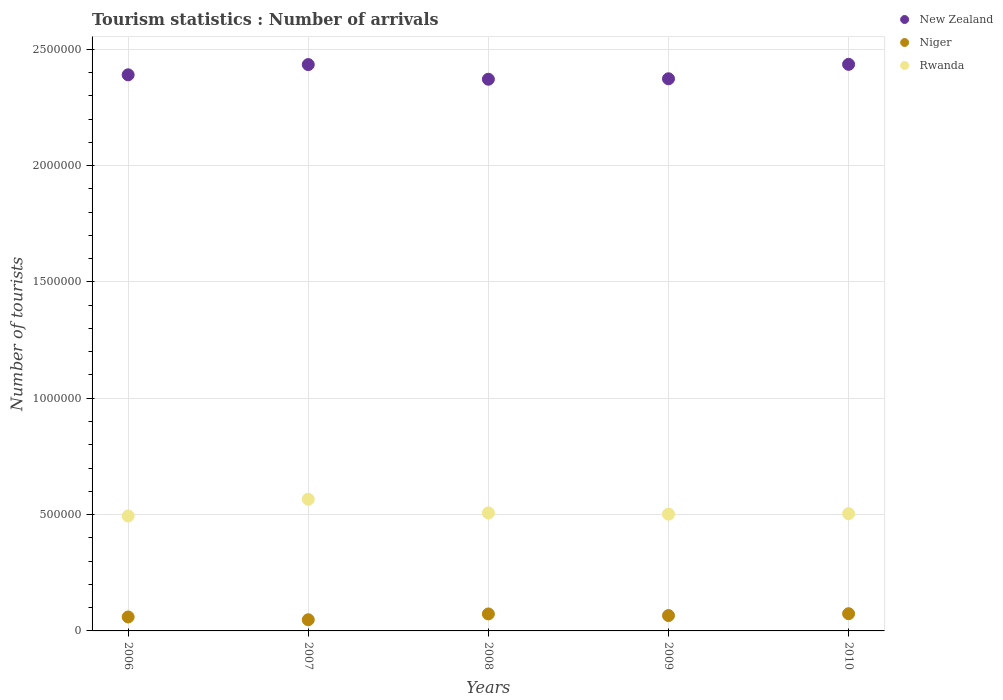How many different coloured dotlines are there?
Keep it short and to the point. 3. What is the number of tourist arrivals in New Zealand in 2007?
Keep it short and to the point. 2.43e+06. Across all years, what is the maximum number of tourist arrivals in Niger?
Make the answer very short. 7.40e+04. Across all years, what is the minimum number of tourist arrivals in Rwanda?
Keep it short and to the point. 4.94e+05. In which year was the number of tourist arrivals in Niger maximum?
Keep it short and to the point. 2010. What is the total number of tourist arrivals in New Zealand in the graph?
Give a very brief answer. 1.20e+07. What is the difference between the number of tourist arrivals in New Zealand in 2006 and that in 2009?
Your response must be concise. 1.70e+04. What is the difference between the number of tourist arrivals in Rwanda in 2008 and the number of tourist arrivals in Niger in 2010?
Give a very brief answer. 4.33e+05. What is the average number of tourist arrivals in Niger per year?
Ensure brevity in your answer.  6.42e+04. In the year 2010, what is the difference between the number of tourist arrivals in Niger and number of tourist arrivals in New Zealand?
Ensure brevity in your answer.  -2.36e+06. In how many years, is the number of tourist arrivals in New Zealand greater than 1300000?
Your answer should be compact. 5. What is the ratio of the number of tourist arrivals in Rwanda in 2006 to that in 2009?
Provide a short and direct response. 0.98. Is the number of tourist arrivals in Niger in 2007 less than that in 2009?
Your response must be concise. Yes. Is the difference between the number of tourist arrivals in Niger in 2008 and 2009 greater than the difference between the number of tourist arrivals in New Zealand in 2008 and 2009?
Keep it short and to the point. Yes. What is the difference between the highest and the lowest number of tourist arrivals in New Zealand?
Your response must be concise. 6.40e+04. In how many years, is the number of tourist arrivals in Rwanda greater than the average number of tourist arrivals in Rwanda taken over all years?
Offer a terse response. 1. Is the sum of the number of tourist arrivals in Niger in 2007 and 2008 greater than the maximum number of tourist arrivals in New Zealand across all years?
Offer a very short reply. No. Is it the case that in every year, the sum of the number of tourist arrivals in Niger and number of tourist arrivals in New Zealand  is greater than the number of tourist arrivals in Rwanda?
Provide a short and direct response. Yes. Does the number of tourist arrivals in Rwanda monotonically increase over the years?
Your answer should be compact. No. Are the values on the major ticks of Y-axis written in scientific E-notation?
Offer a terse response. No. Does the graph contain any zero values?
Your answer should be compact. No. Does the graph contain grids?
Your answer should be very brief. Yes. How many legend labels are there?
Offer a very short reply. 3. How are the legend labels stacked?
Offer a terse response. Vertical. What is the title of the graph?
Give a very brief answer. Tourism statistics : Number of arrivals. What is the label or title of the X-axis?
Provide a short and direct response. Years. What is the label or title of the Y-axis?
Your answer should be very brief. Number of tourists. What is the Number of tourists of New Zealand in 2006?
Give a very brief answer. 2.39e+06. What is the Number of tourists of Niger in 2006?
Ensure brevity in your answer.  6.00e+04. What is the Number of tourists in Rwanda in 2006?
Give a very brief answer. 4.94e+05. What is the Number of tourists in New Zealand in 2007?
Ensure brevity in your answer.  2.43e+06. What is the Number of tourists of Niger in 2007?
Provide a short and direct response. 4.80e+04. What is the Number of tourists in Rwanda in 2007?
Provide a succinct answer. 5.66e+05. What is the Number of tourists of New Zealand in 2008?
Offer a terse response. 2.37e+06. What is the Number of tourists in Niger in 2008?
Offer a terse response. 7.30e+04. What is the Number of tourists in Rwanda in 2008?
Your response must be concise. 5.07e+05. What is the Number of tourists of New Zealand in 2009?
Provide a succinct answer. 2.37e+06. What is the Number of tourists of Niger in 2009?
Make the answer very short. 6.60e+04. What is the Number of tourists in Rwanda in 2009?
Offer a very short reply. 5.02e+05. What is the Number of tourists of New Zealand in 2010?
Provide a succinct answer. 2.44e+06. What is the Number of tourists of Niger in 2010?
Keep it short and to the point. 7.40e+04. What is the Number of tourists of Rwanda in 2010?
Offer a terse response. 5.04e+05. Across all years, what is the maximum Number of tourists in New Zealand?
Make the answer very short. 2.44e+06. Across all years, what is the maximum Number of tourists in Niger?
Your answer should be compact. 7.40e+04. Across all years, what is the maximum Number of tourists of Rwanda?
Keep it short and to the point. 5.66e+05. Across all years, what is the minimum Number of tourists in New Zealand?
Your answer should be compact. 2.37e+06. Across all years, what is the minimum Number of tourists in Niger?
Keep it short and to the point. 4.80e+04. Across all years, what is the minimum Number of tourists in Rwanda?
Provide a short and direct response. 4.94e+05. What is the total Number of tourists of New Zealand in the graph?
Provide a short and direct response. 1.20e+07. What is the total Number of tourists in Niger in the graph?
Your answer should be very brief. 3.21e+05. What is the total Number of tourists of Rwanda in the graph?
Your answer should be compact. 2.57e+06. What is the difference between the Number of tourists of New Zealand in 2006 and that in 2007?
Ensure brevity in your answer.  -4.40e+04. What is the difference between the Number of tourists of Niger in 2006 and that in 2007?
Give a very brief answer. 1.20e+04. What is the difference between the Number of tourists in Rwanda in 2006 and that in 2007?
Offer a very short reply. -7.20e+04. What is the difference between the Number of tourists of New Zealand in 2006 and that in 2008?
Provide a succinct answer. 1.90e+04. What is the difference between the Number of tourists of Niger in 2006 and that in 2008?
Keep it short and to the point. -1.30e+04. What is the difference between the Number of tourists in Rwanda in 2006 and that in 2008?
Keep it short and to the point. -1.30e+04. What is the difference between the Number of tourists in New Zealand in 2006 and that in 2009?
Offer a very short reply. 1.70e+04. What is the difference between the Number of tourists of Niger in 2006 and that in 2009?
Provide a short and direct response. -6000. What is the difference between the Number of tourists in Rwanda in 2006 and that in 2009?
Your answer should be very brief. -8000. What is the difference between the Number of tourists in New Zealand in 2006 and that in 2010?
Your answer should be very brief. -4.50e+04. What is the difference between the Number of tourists of Niger in 2006 and that in 2010?
Make the answer very short. -1.40e+04. What is the difference between the Number of tourists in New Zealand in 2007 and that in 2008?
Provide a short and direct response. 6.30e+04. What is the difference between the Number of tourists in Niger in 2007 and that in 2008?
Make the answer very short. -2.50e+04. What is the difference between the Number of tourists of Rwanda in 2007 and that in 2008?
Ensure brevity in your answer.  5.90e+04. What is the difference between the Number of tourists of New Zealand in 2007 and that in 2009?
Keep it short and to the point. 6.10e+04. What is the difference between the Number of tourists in Niger in 2007 and that in 2009?
Provide a succinct answer. -1.80e+04. What is the difference between the Number of tourists in Rwanda in 2007 and that in 2009?
Offer a very short reply. 6.40e+04. What is the difference between the Number of tourists in New Zealand in 2007 and that in 2010?
Make the answer very short. -1000. What is the difference between the Number of tourists in Niger in 2007 and that in 2010?
Ensure brevity in your answer.  -2.60e+04. What is the difference between the Number of tourists in Rwanda in 2007 and that in 2010?
Make the answer very short. 6.20e+04. What is the difference between the Number of tourists of New Zealand in 2008 and that in 2009?
Your answer should be very brief. -2000. What is the difference between the Number of tourists in Niger in 2008 and that in 2009?
Provide a short and direct response. 7000. What is the difference between the Number of tourists of Rwanda in 2008 and that in 2009?
Your answer should be very brief. 5000. What is the difference between the Number of tourists in New Zealand in 2008 and that in 2010?
Your response must be concise. -6.40e+04. What is the difference between the Number of tourists in Niger in 2008 and that in 2010?
Offer a terse response. -1000. What is the difference between the Number of tourists of Rwanda in 2008 and that in 2010?
Your answer should be compact. 3000. What is the difference between the Number of tourists in New Zealand in 2009 and that in 2010?
Give a very brief answer. -6.20e+04. What is the difference between the Number of tourists in Niger in 2009 and that in 2010?
Ensure brevity in your answer.  -8000. What is the difference between the Number of tourists in Rwanda in 2009 and that in 2010?
Provide a succinct answer. -2000. What is the difference between the Number of tourists of New Zealand in 2006 and the Number of tourists of Niger in 2007?
Provide a succinct answer. 2.34e+06. What is the difference between the Number of tourists in New Zealand in 2006 and the Number of tourists in Rwanda in 2007?
Your response must be concise. 1.82e+06. What is the difference between the Number of tourists in Niger in 2006 and the Number of tourists in Rwanda in 2007?
Offer a terse response. -5.06e+05. What is the difference between the Number of tourists of New Zealand in 2006 and the Number of tourists of Niger in 2008?
Offer a very short reply. 2.32e+06. What is the difference between the Number of tourists in New Zealand in 2006 and the Number of tourists in Rwanda in 2008?
Ensure brevity in your answer.  1.88e+06. What is the difference between the Number of tourists in Niger in 2006 and the Number of tourists in Rwanda in 2008?
Your answer should be compact. -4.47e+05. What is the difference between the Number of tourists in New Zealand in 2006 and the Number of tourists in Niger in 2009?
Offer a very short reply. 2.32e+06. What is the difference between the Number of tourists in New Zealand in 2006 and the Number of tourists in Rwanda in 2009?
Keep it short and to the point. 1.89e+06. What is the difference between the Number of tourists in Niger in 2006 and the Number of tourists in Rwanda in 2009?
Your response must be concise. -4.42e+05. What is the difference between the Number of tourists in New Zealand in 2006 and the Number of tourists in Niger in 2010?
Your answer should be compact. 2.32e+06. What is the difference between the Number of tourists of New Zealand in 2006 and the Number of tourists of Rwanda in 2010?
Provide a short and direct response. 1.89e+06. What is the difference between the Number of tourists in Niger in 2006 and the Number of tourists in Rwanda in 2010?
Keep it short and to the point. -4.44e+05. What is the difference between the Number of tourists in New Zealand in 2007 and the Number of tourists in Niger in 2008?
Provide a short and direct response. 2.36e+06. What is the difference between the Number of tourists in New Zealand in 2007 and the Number of tourists in Rwanda in 2008?
Offer a very short reply. 1.93e+06. What is the difference between the Number of tourists of Niger in 2007 and the Number of tourists of Rwanda in 2008?
Offer a very short reply. -4.59e+05. What is the difference between the Number of tourists of New Zealand in 2007 and the Number of tourists of Niger in 2009?
Offer a terse response. 2.37e+06. What is the difference between the Number of tourists in New Zealand in 2007 and the Number of tourists in Rwanda in 2009?
Offer a very short reply. 1.93e+06. What is the difference between the Number of tourists in Niger in 2007 and the Number of tourists in Rwanda in 2009?
Your response must be concise. -4.54e+05. What is the difference between the Number of tourists of New Zealand in 2007 and the Number of tourists of Niger in 2010?
Offer a terse response. 2.36e+06. What is the difference between the Number of tourists in New Zealand in 2007 and the Number of tourists in Rwanda in 2010?
Your response must be concise. 1.93e+06. What is the difference between the Number of tourists in Niger in 2007 and the Number of tourists in Rwanda in 2010?
Your answer should be compact. -4.56e+05. What is the difference between the Number of tourists in New Zealand in 2008 and the Number of tourists in Niger in 2009?
Your answer should be compact. 2.30e+06. What is the difference between the Number of tourists in New Zealand in 2008 and the Number of tourists in Rwanda in 2009?
Offer a very short reply. 1.87e+06. What is the difference between the Number of tourists in Niger in 2008 and the Number of tourists in Rwanda in 2009?
Offer a terse response. -4.29e+05. What is the difference between the Number of tourists in New Zealand in 2008 and the Number of tourists in Niger in 2010?
Keep it short and to the point. 2.30e+06. What is the difference between the Number of tourists of New Zealand in 2008 and the Number of tourists of Rwanda in 2010?
Provide a succinct answer. 1.87e+06. What is the difference between the Number of tourists in Niger in 2008 and the Number of tourists in Rwanda in 2010?
Give a very brief answer. -4.31e+05. What is the difference between the Number of tourists of New Zealand in 2009 and the Number of tourists of Niger in 2010?
Offer a terse response. 2.30e+06. What is the difference between the Number of tourists in New Zealand in 2009 and the Number of tourists in Rwanda in 2010?
Your answer should be very brief. 1.87e+06. What is the difference between the Number of tourists of Niger in 2009 and the Number of tourists of Rwanda in 2010?
Offer a very short reply. -4.38e+05. What is the average Number of tourists of New Zealand per year?
Give a very brief answer. 2.40e+06. What is the average Number of tourists of Niger per year?
Your answer should be very brief. 6.42e+04. What is the average Number of tourists in Rwanda per year?
Your answer should be compact. 5.15e+05. In the year 2006, what is the difference between the Number of tourists in New Zealand and Number of tourists in Niger?
Your response must be concise. 2.33e+06. In the year 2006, what is the difference between the Number of tourists in New Zealand and Number of tourists in Rwanda?
Provide a short and direct response. 1.90e+06. In the year 2006, what is the difference between the Number of tourists of Niger and Number of tourists of Rwanda?
Your response must be concise. -4.34e+05. In the year 2007, what is the difference between the Number of tourists in New Zealand and Number of tourists in Niger?
Offer a terse response. 2.39e+06. In the year 2007, what is the difference between the Number of tourists of New Zealand and Number of tourists of Rwanda?
Keep it short and to the point. 1.87e+06. In the year 2007, what is the difference between the Number of tourists in Niger and Number of tourists in Rwanda?
Offer a very short reply. -5.18e+05. In the year 2008, what is the difference between the Number of tourists in New Zealand and Number of tourists in Niger?
Make the answer very short. 2.30e+06. In the year 2008, what is the difference between the Number of tourists of New Zealand and Number of tourists of Rwanda?
Ensure brevity in your answer.  1.86e+06. In the year 2008, what is the difference between the Number of tourists of Niger and Number of tourists of Rwanda?
Offer a very short reply. -4.34e+05. In the year 2009, what is the difference between the Number of tourists of New Zealand and Number of tourists of Niger?
Provide a succinct answer. 2.31e+06. In the year 2009, what is the difference between the Number of tourists in New Zealand and Number of tourists in Rwanda?
Provide a short and direct response. 1.87e+06. In the year 2009, what is the difference between the Number of tourists in Niger and Number of tourists in Rwanda?
Offer a very short reply. -4.36e+05. In the year 2010, what is the difference between the Number of tourists of New Zealand and Number of tourists of Niger?
Provide a short and direct response. 2.36e+06. In the year 2010, what is the difference between the Number of tourists in New Zealand and Number of tourists in Rwanda?
Provide a short and direct response. 1.93e+06. In the year 2010, what is the difference between the Number of tourists in Niger and Number of tourists in Rwanda?
Keep it short and to the point. -4.30e+05. What is the ratio of the Number of tourists in New Zealand in 2006 to that in 2007?
Your answer should be very brief. 0.98. What is the ratio of the Number of tourists of Rwanda in 2006 to that in 2007?
Ensure brevity in your answer.  0.87. What is the ratio of the Number of tourists in Niger in 2006 to that in 2008?
Provide a short and direct response. 0.82. What is the ratio of the Number of tourists in Rwanda in 2006 to that in 2008?
Make the answer very short. 0.97. What is the ratio of the Number of tourists of New Zealand in 2006 to that in 2009?
Ensure brevity in your answer.  1.01. What is the ratio of the Number of tourists of Niger in 2006 to that in 2009?
Keep it short and to the point. 0.91. What is the ratio of the Number of tourists of Rwanda in 2006 to that in 2009?
Give a very brief answer. 0.98. What is the ratio of the Number of tourists in New Zealand in 2006 to that in 2010?
Give a very brief answer. 0.98. What is the ratio of the Number of tourists in Niger in 2006 to that in 2010?
Make the answer very short. 0.81. What is the ratio of the Number of tourists in Rwanda in 2006 to that in 2010?
Ensure brevity in your answer.  0.98. What is the ratio of the Number of tourists of New Zealand in 2007 to that in 2008?
Provide a short and direct response. 1.03. What is the ratio of the Number of tourists of Niger in 2007 to that in 2008?
Your answer should be very brief. 0.66. What is the ratio of the Number of tourists of Rwanda in 2007 to that in 2008?
Provide a short and direct response. 1.12. What is the ratio of the Number of tourists of New Zealand in 2007 to that in 2009?
Ensure brevity in your answer.  1.03. What is the ratio of the Number of tourists of Niger in 2007 to that in 2009?
Your answer should be very brief. 0.73. What is the ratio of the Number of tourists of Rwanda in 2007 to that in 2009?
Keep it short and to the point. 1.13. What is the ratio of the Number of tourists of New Zealand in 2007 to that in 2010?
Your response must be concise. 1. What is the ratio of the Number of tourists in Niger in 2007 to that in 2010?
Offer a very short reply. 0.65. What is the ratio of the Number of tourists in Rwanda in 2007 to that in 2010?
Keep it short and to the point. 1.12. What is the ratio of the Number of tourists in Niger in 2008 to that in 2009?
Offer a terse response. 1.11. What is the ratio of the Number of tourists in Rwanda in 2008 to that in 2009?
Ensure brevity in your answer.  1.01. What is the ratio of the Number of tourists in New Zealand in 2008 to that in 2010?
Offer a terse response. 0.97. What is the ratio of the Number of tourists in Niger in 2008 to that in 2010?
Keep it short and to the point. 0.99. What is the ratio of the Number of tourists of New Zealand in 2009 to that in 2010?
Provide a succinct answer. 0.97. What is the ratio of the Number of tourists in Niger in 2009 to that in 2010?
Make the answer very short. 0.89. What is the ratio of the Number of tourists in Rwanda in 2009 to that in 2010?
Ensure brevity in your answer.  1. What is the difference between the highest and the second highest Number of tourists of New Zealand?
Ensure brevity in your answer.  1000. What is the difference between the highest and the second highest Number of tourists in Niger?
Offer a terse response. 1000. What is the difference between the highest and the second highest Number of tourists of Rwanda?
Provide a succinct answer. 5.90e+04. What is the difference between the highest and the lowest Number of tourists in New Zealand?
Offer a terse response. 6.40e+04. What is the difference between the highest and the lowest Number of tourists of Niger?
Keep it short and to the point. 2.60e+04. What is the difference between the highest and the lowest Number of tourists of Rwanda?
Provide a short and direct response. 7.20e+04. 